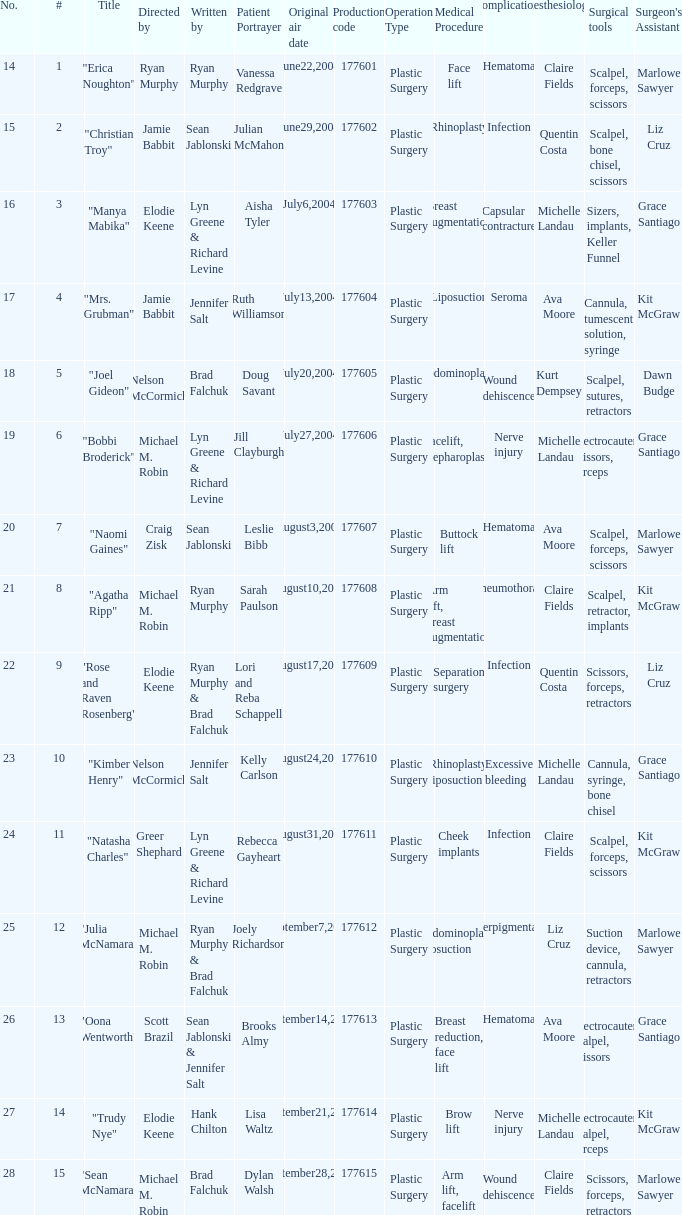What is the highest numbered episode with patient portrayer doug savant? 5.0. 